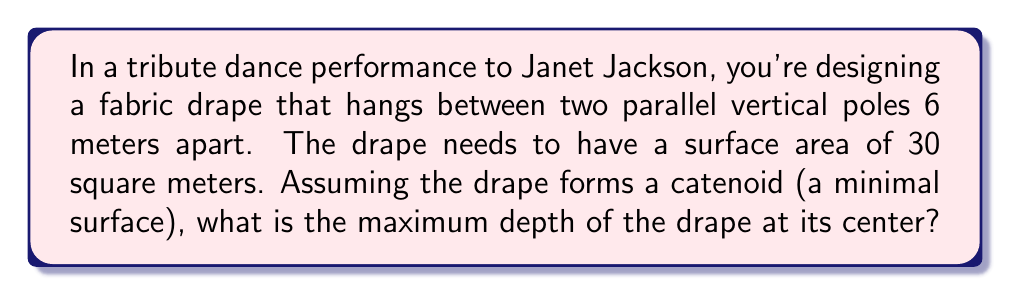Show me your answer to this math problem. To solve this problem, we'll use the equations for a catenoid, which is a minimal surface formed by rotating a catenary curve around an axis.

Step 1: The equation for the surface area of a catenoid is:
$$A = 2\pi a^2 \left(\sinh\left(\frac{L}{2a}\right) - \frac{L}{2a}\right)$$
Where $A$ is the surface area, $a$ is the scale parameter, and $L$ is the distance between the poles.

Step 2: We're given $A = 30$ m² and $L = 6$ m. Let's substitute these values:
$$30 = 2\pi a^2 \left(\sinh\left(\frac{3}{a}\right) - \frac{3}{a}\right)$$

Step 3: This equation can't be solved analytically, so we need to use numerical methods. Using a computer or graphing calculator, we can find that $a \approx 1.7321$ m.

Step 4: The equation for the catenoid surface is:
$$z(x, y) = a \cosh\left(\frac{\sqrt{x^2 + y^2}}{a}\right)$$

Step 5: The maximum depth occurs at the center where $x = y = 0$. So:
$$z_{\text{max}} = a \cosh\left(\frac{0}{a}\right) = a \cosh(0) = a$$

Step 6: Substitute our value for $a$:
$$z_{\text{max}} \approx 1.7321 \text{ m}$$

This is the maximum depth of the drape at its center.
Answer: $1.7321$ m 